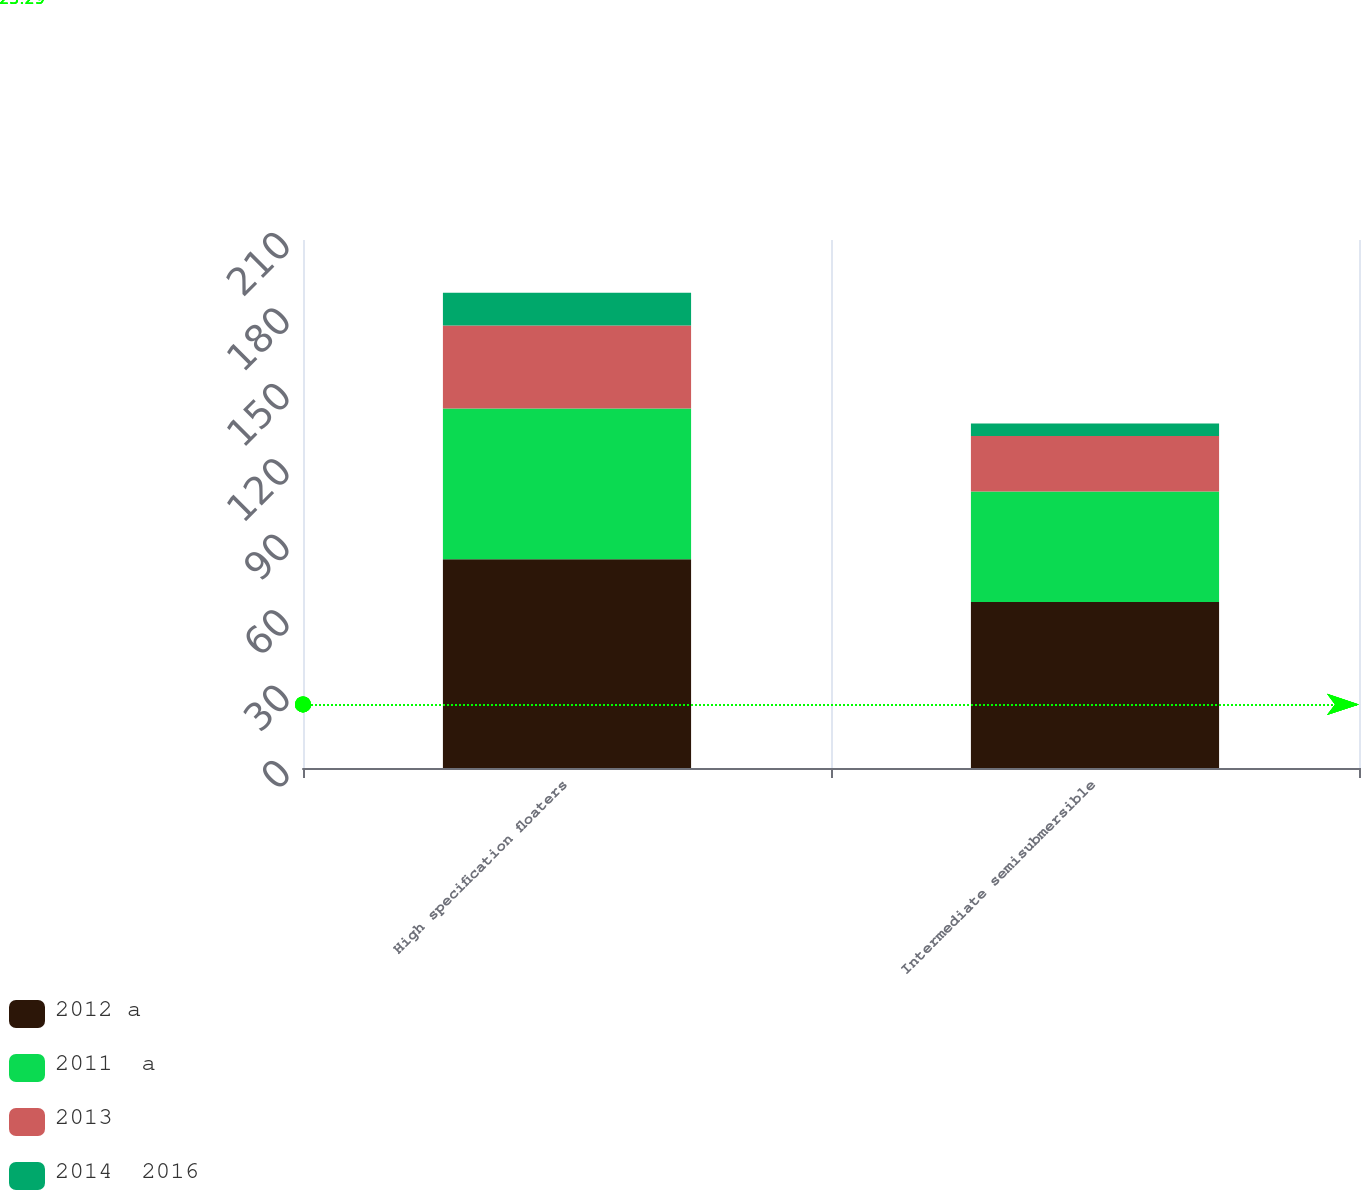Convert chart to OTSL. <chart><loc_0><loc_0><loc_500><loc_500><stacked_bar_chart><ecel><fcel>High specification floaters<fcel>Intermediate semisubmersible<nl><fcel>2012 a<fcel>83<fcel>66<nl><fcel>2011  a<fcel>60<fcel>44<nl><fcel>2013<fcel>33<fcel>22<nl><fcel>2014  2016<fcel>13<fcel>5<nl></chart> 